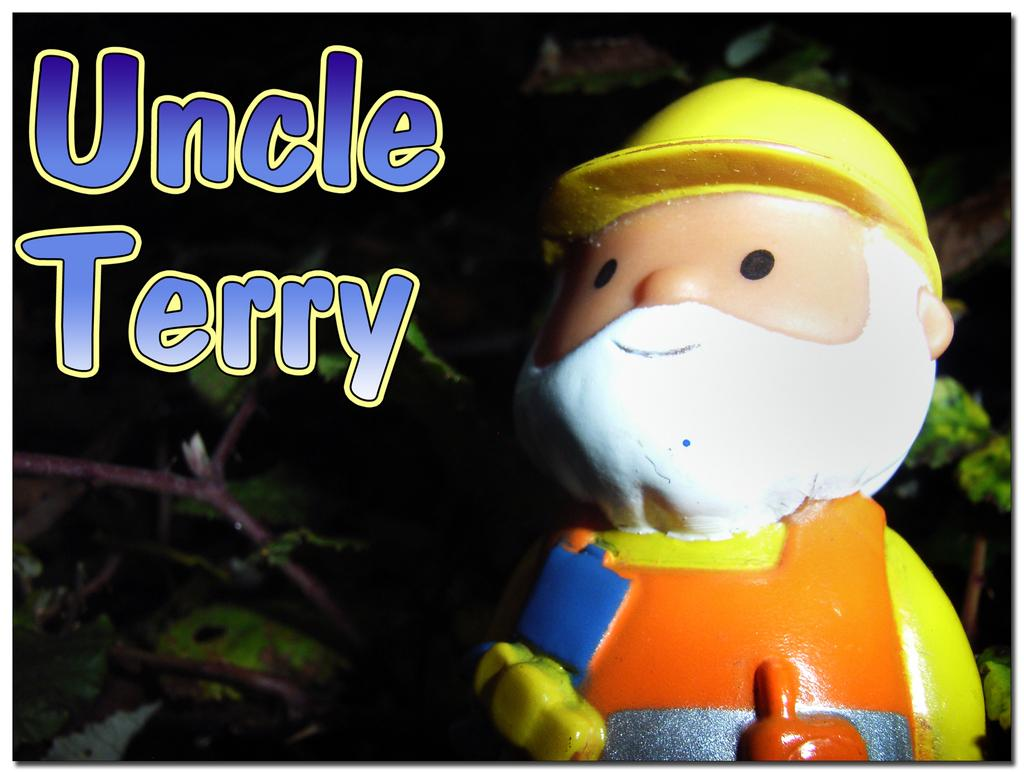What object is located on the right side of the image? There is a toy on the right side of the image. What type of vegetation can be seen in the background of the image? There are leaves and stems of a plant in the background of the image. Where is the text in the image located? The text in blue color is on the left top of the image. How many rabbits can be seen in the image? There are no rabbits present in the image. What type of knowledge is being conveyed by the eye in the image? There is no eye present in the image, so no knowledge can be conveyed by it. 